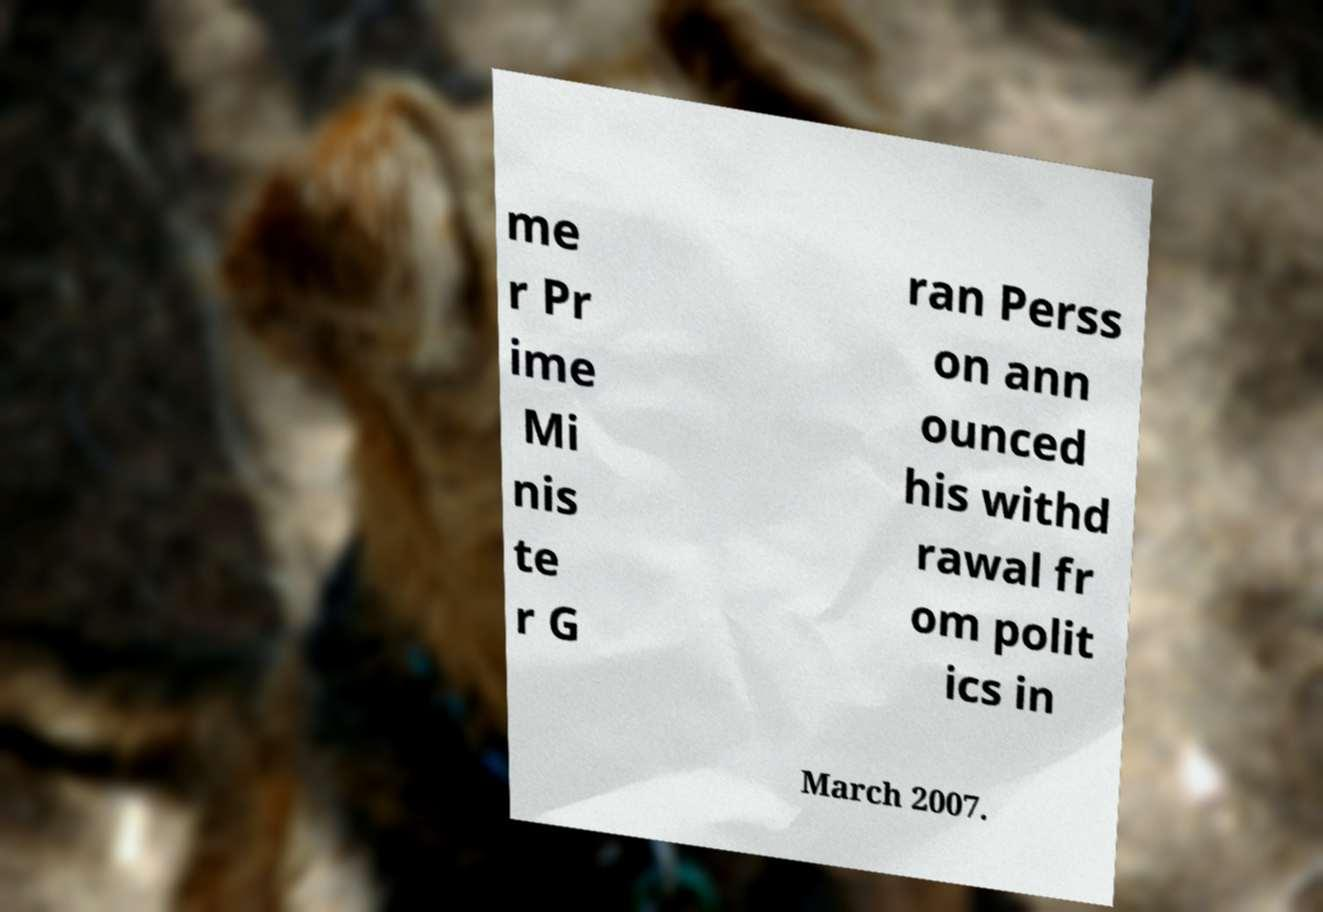What messages or text are displayed in this image? I need them in a readable, typed format. me r Pr ime Mi nis te r G ran Perss on ann ounced his withd rawal fr om polit ics in March 2007. 